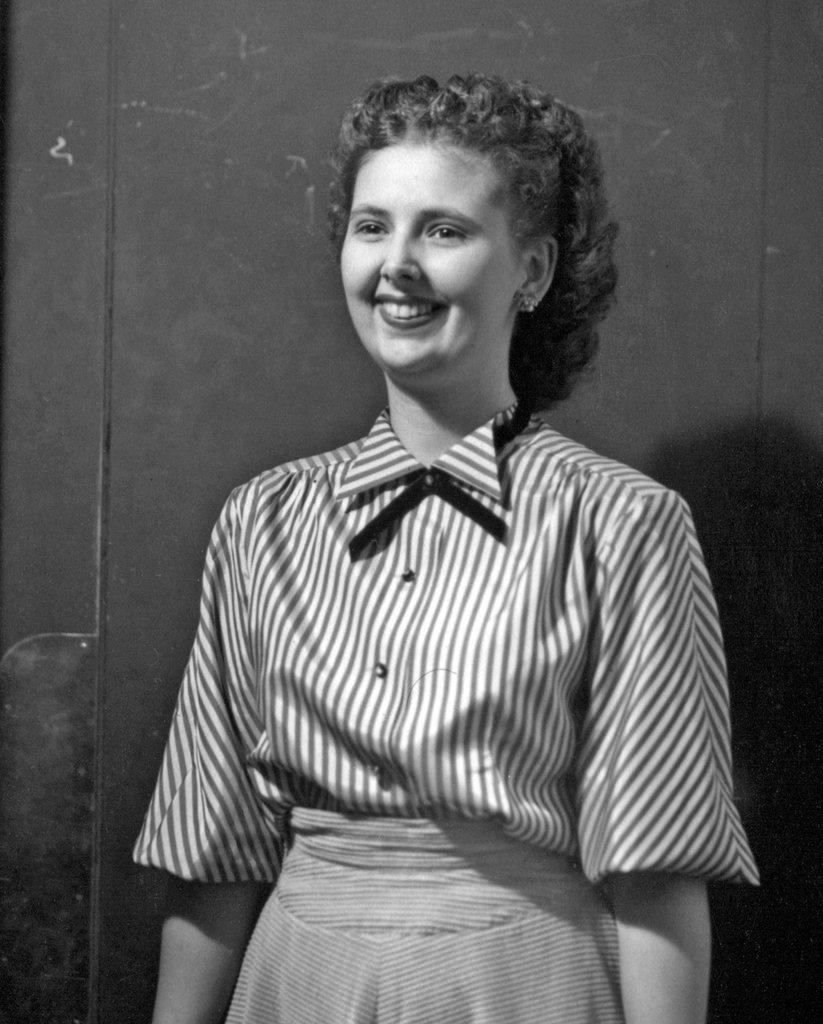What is the main subject of the image? There is a person standing in the image. What is the color scheme of the image? The image is in black and white. What type of pizza does the person in the image enjoy eating? There is no pizza present in the image, so it cannot be determined what type of pizza the person might enjoy eating. 